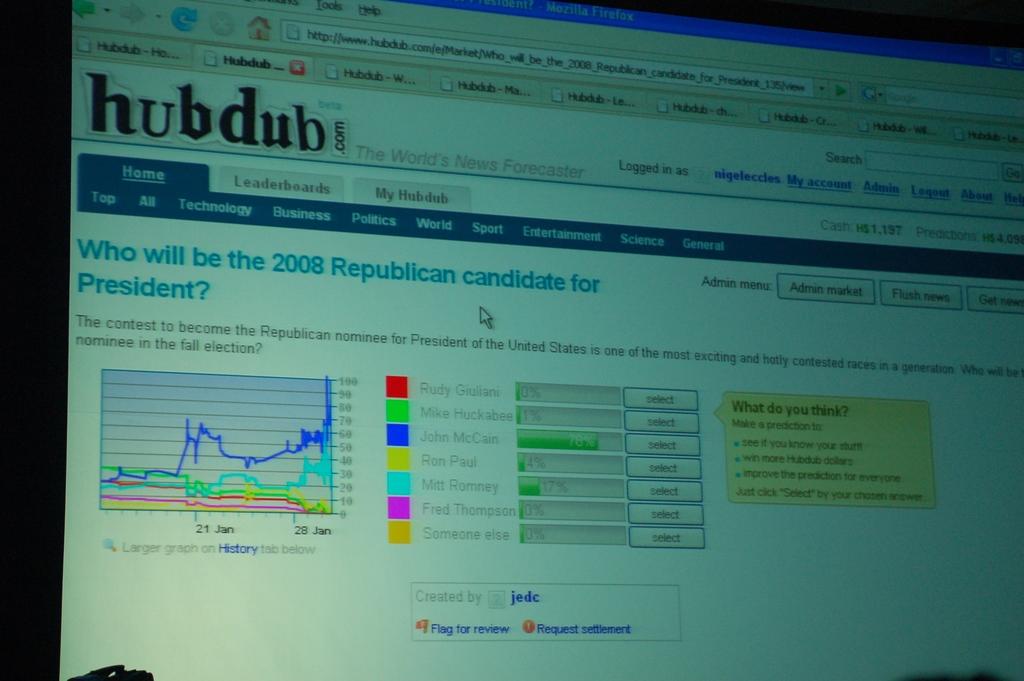What is a heading on the web page?
Your answer should be very brief. Hubdub. Wjay question is in blue on the screen?
Your response must be concise. Who will be the 2008 republican candidate for president?. 